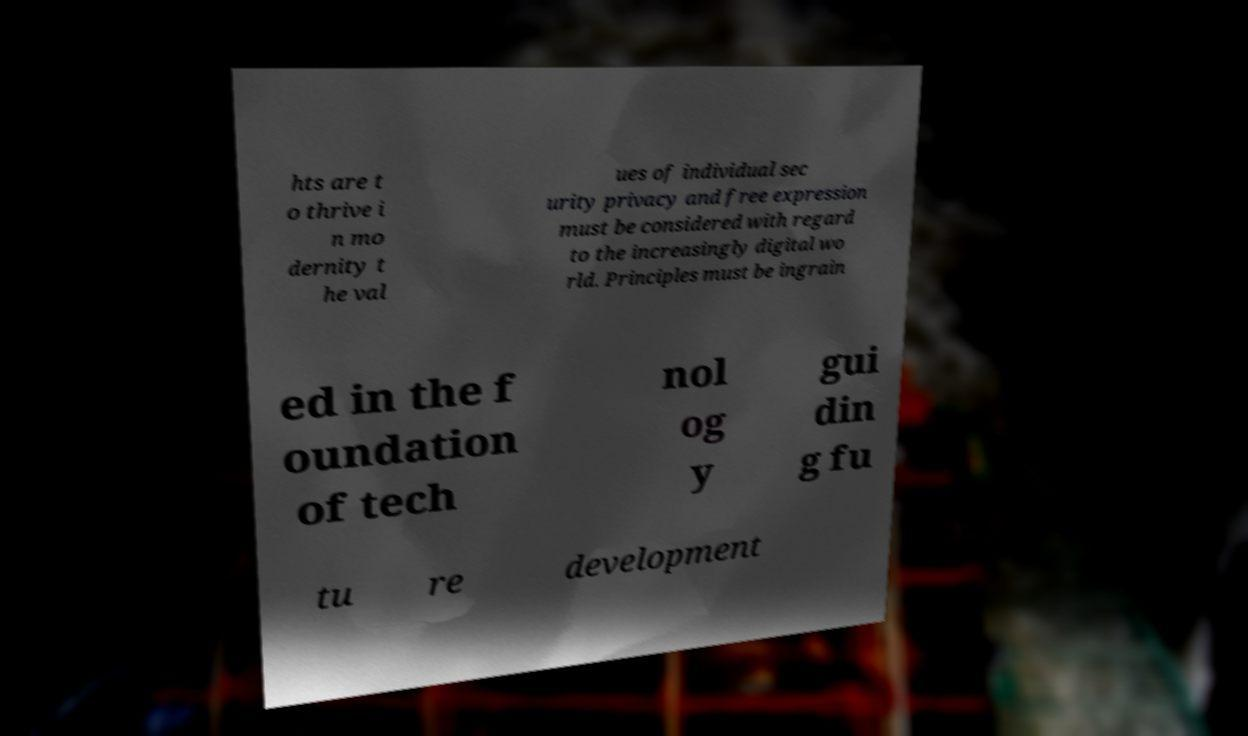Please read and relay the text visible in this image. What does it say? hts are t o thrive i n mo dernity t he val ues of individual sec urity privacy and free expression must be considered with regard to the increasingly digital wo rld. Principles must be ingrain ed in the f oundation of tech nol og y gui din g fu tu re development 